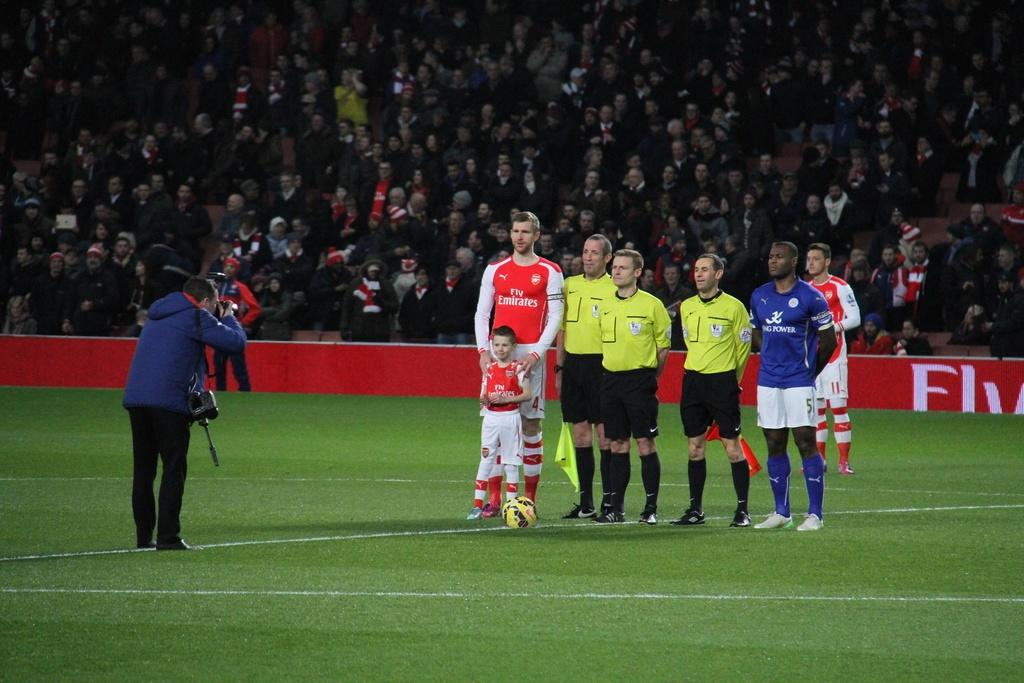<image>
Offer a succinct explanation of the picture presented. man with camera taking pictures of man and boy with fly emerates jerseys, 3 referees and a player with big power jerseyand another fly emerates player in the background 